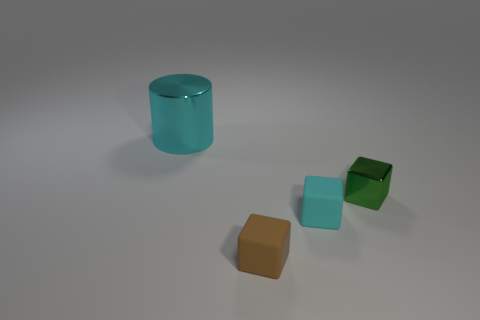What material is the cyan object in front of the object to the right of the cyan object that is to the right of the cyan shiny thing?
Ensure brevity in your answer.  Rubber. Do the brown matte block and the green metallic thing have the same size?
Ensure brevity in your answer.  Yes. What material is the small green object?
Ensure brevity in your answer.  Metal. There is another thing that is the same color as the large shiny thing; what is it made of?
Your response must be concise. Rubber. There is a shiny thing that is to the right of the small brown thing; is it the same shape as the tiny brown thing?
Offer a terse response. Yes. What number of objects are either tiny cyan matte things or small green metallic things?
Your answer should be very brief. 2. Does the tiny cube right of the small cyan object have the same material as the tiny cyan object?
Your response must be concise. No. The green block has what size?
Offer a very short reply. Small. There is a tiny object that is the same color as the big cylinder; what shape is it?
Your response must be concise. Cube. How many balls are either tiny brown rubber objects or cyan metallic things?
Make the answer very short. 0. 